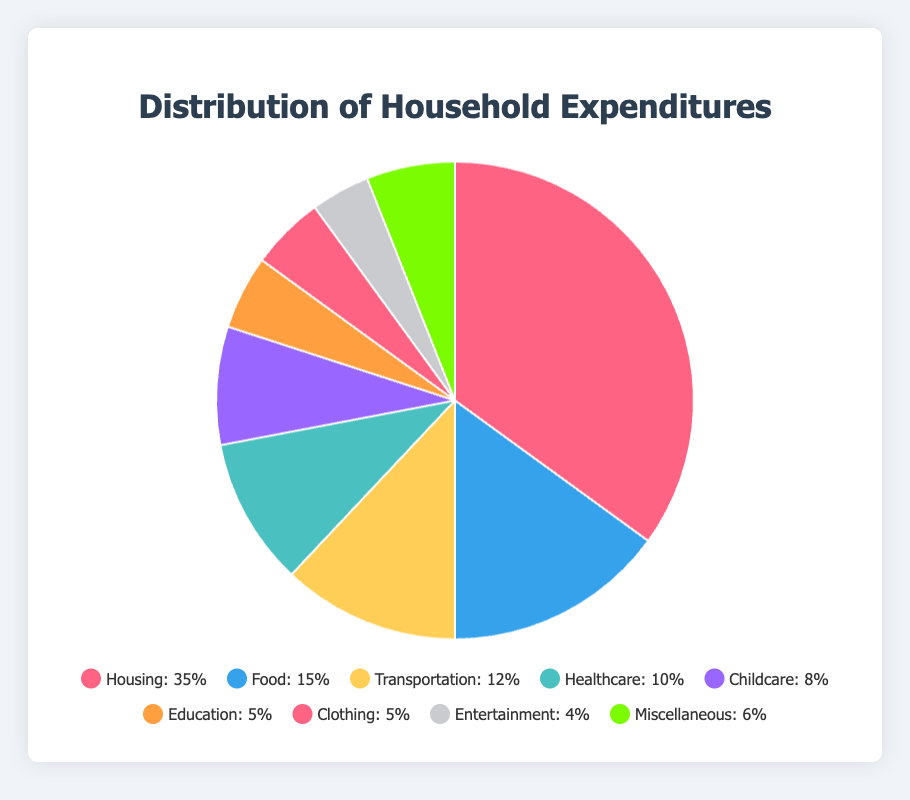What percentage of household expenditures is spent on Food and Clothing combined? First, locate the percentages for Food and Clothing in the pie chart, which are 15% and 5% respectively. Add these two values together: 15% + 5% = 20%.
Answer: 20% Which category accounts for the highest percentage of household expenditures? Look at the pie chart and identify the segment with the largest area. The largest segment is Housing, which accounts for 35% of the expenditures.
Answer: Housing Is the expenditure on Transportation greater than the expenditure on Childcare? Compare the percentages of Transportation and Childcare in the pie chart. Transportation is 12%, while Childcare is 8%. Since 12% is greater than 8%, expenditure on Transportation is greater.
Answer: Yes What is the percentage difference between Housing and Miscellaneous expenditures? Locate the percentages for Housing and Miscellaneous from the pie chart, which are 35% and 6% respectively. Subtract the smaller percentage from the larger one: 35% - 6% = 29%.
Answer: 29% Which categories together make up exactly 30% of the household expenditures? Identify the percentages of each category in the pie chart and find combinations that add up to 30%. Childcare (8%) + Education (5%) + Clothing (5%) + Entertainment (4%) + Miscellaneous (6%) = 28%. However, Food (15%) + Healthcare (10%) + Clothing (5%) = 30%.
Answer: Food, Healthcare, Clothing What percentage of the expenditures goes to categories related to children, specifically Childcare and Education? Find the percentages of Childcare and Education in the pie chart, which are 8% and 5% respectively. Add these two values together: 8% + 5% = 13%.
Answer: 13% Compare the expenditures on Entertainment and Clothing. Which one is higher and by how much? Find the percentages of Entertainment and Clothing in the pie chart. Entertainment is 4%, and Clothing is 5%. Subtract the smaller value from the larger one: 5% - 4% = 1%. Clothing is 1% higher than Entertainment.
Answer: Clothing, 1% Which color represents Healthcare in the pie chart? Look at the pie chart and identify the color corresponding to Healthcare. According to the defined colors, Healthcare is represented by the fourth segment after Housing, Food, and Transportation, which in this pie chart is typically a shade of turquoise.
Answer: Turquoise How does the expenditure on Entertainment compare to the combined expenditure on Healthcare and Miscellaneous? Find the percentages for Entertainment (4%), Healthcare (10%), and Miscellaneous (6%) in the pie chart. Add Healthcare and Miscellaneous: 10% + 6% = 16%. Compare this with Entertainment. 16% is greater than 4%.
Answer: Less If we combine Transportation and Clothing expenditures, do they exceed the expenditure on Healthcare? Find the percentages for Transportation (12%), Clothing (5%), and Healthcare (10%) in the pie chart. Add Transportation and Clothing: 12% + 5% = 17%. Compare this with Healthcare. 17% exceeds 10%.
Answer: Yes 